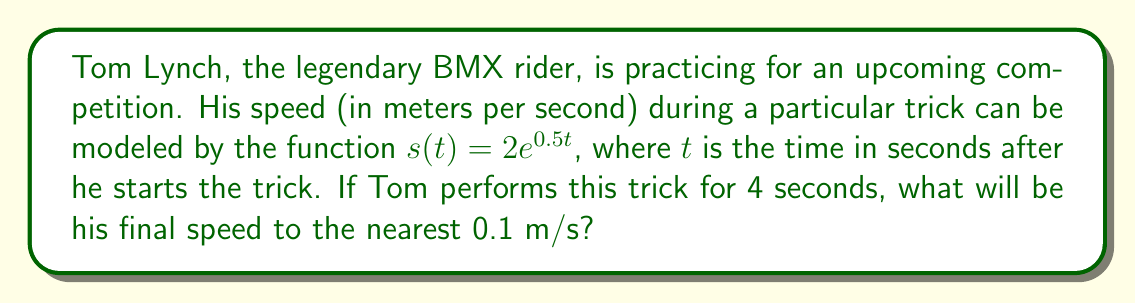Can you answer this question? To solve this problem, we need to follow these steps:

1) We are given the function $s(t) = 2e^{0.5t}$, where $s$ is the speed in m/s and $t$ is the time in seconds.

2) We need to find the speed at $t = 4$ seconds.

3) Let's substitute $t = 4$ into the function:

   $s(4) = 2e^{0.5(4)}$

4) Simplify the exponent:
   
   $s(4) = 2e^2$

5) Now we need to calculate this value. Let's break it down:

   $e^2 \approx 7.3891$ (using a calculator or e-table)

   $2 * 7.3891 = 14.7782$

6) The question asks for the answer to the nearest 0.1 m/s, so we need to round this to one decimal place.

   $14.7782$ rounded to one decimal place is $14.8$

Therefore, Tom Lynch's speed after 4 seconds will be approximately 14.8 m/s.
Answer: 14.8 m/s 